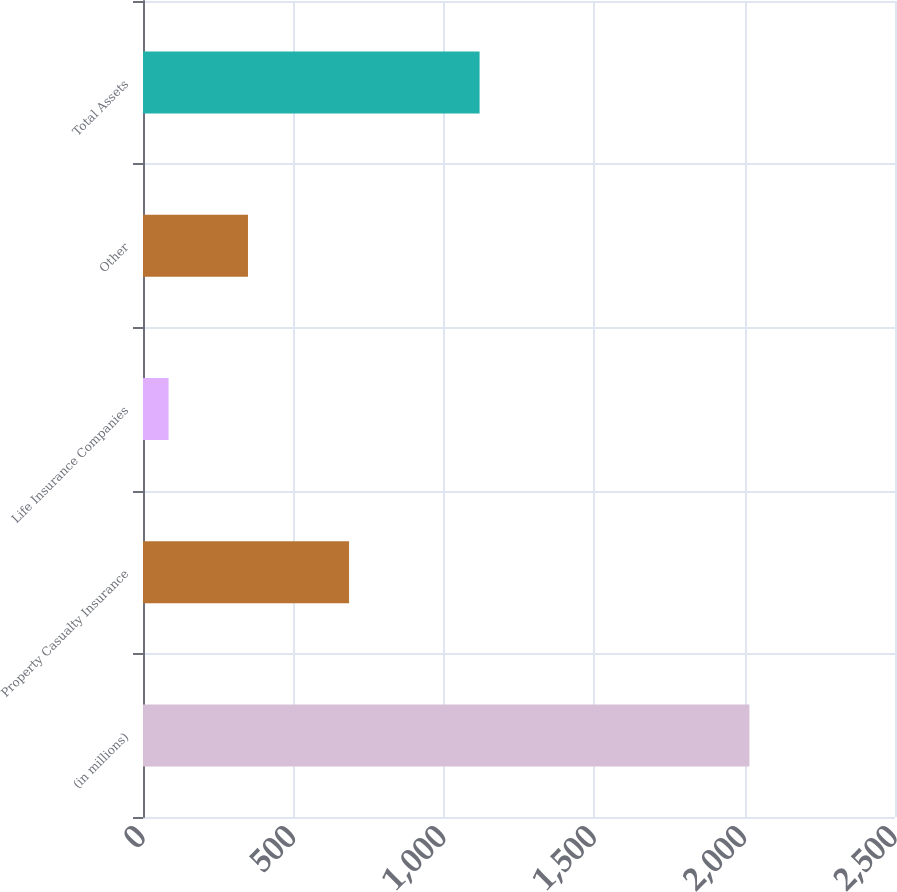Convert chart to OTSL. <chart><loc_0><loc_0><loc_500><loc_500><bar_chart><fcel>(in millions)<fcel>Property Casualty Insurance<fcel>Life Insurance Companies<fcel>Other<fcel>Total Assets<nl><fcel>2016<fcel>685<fcel>85<fcel>349<fcel>1119<nl></chart> 